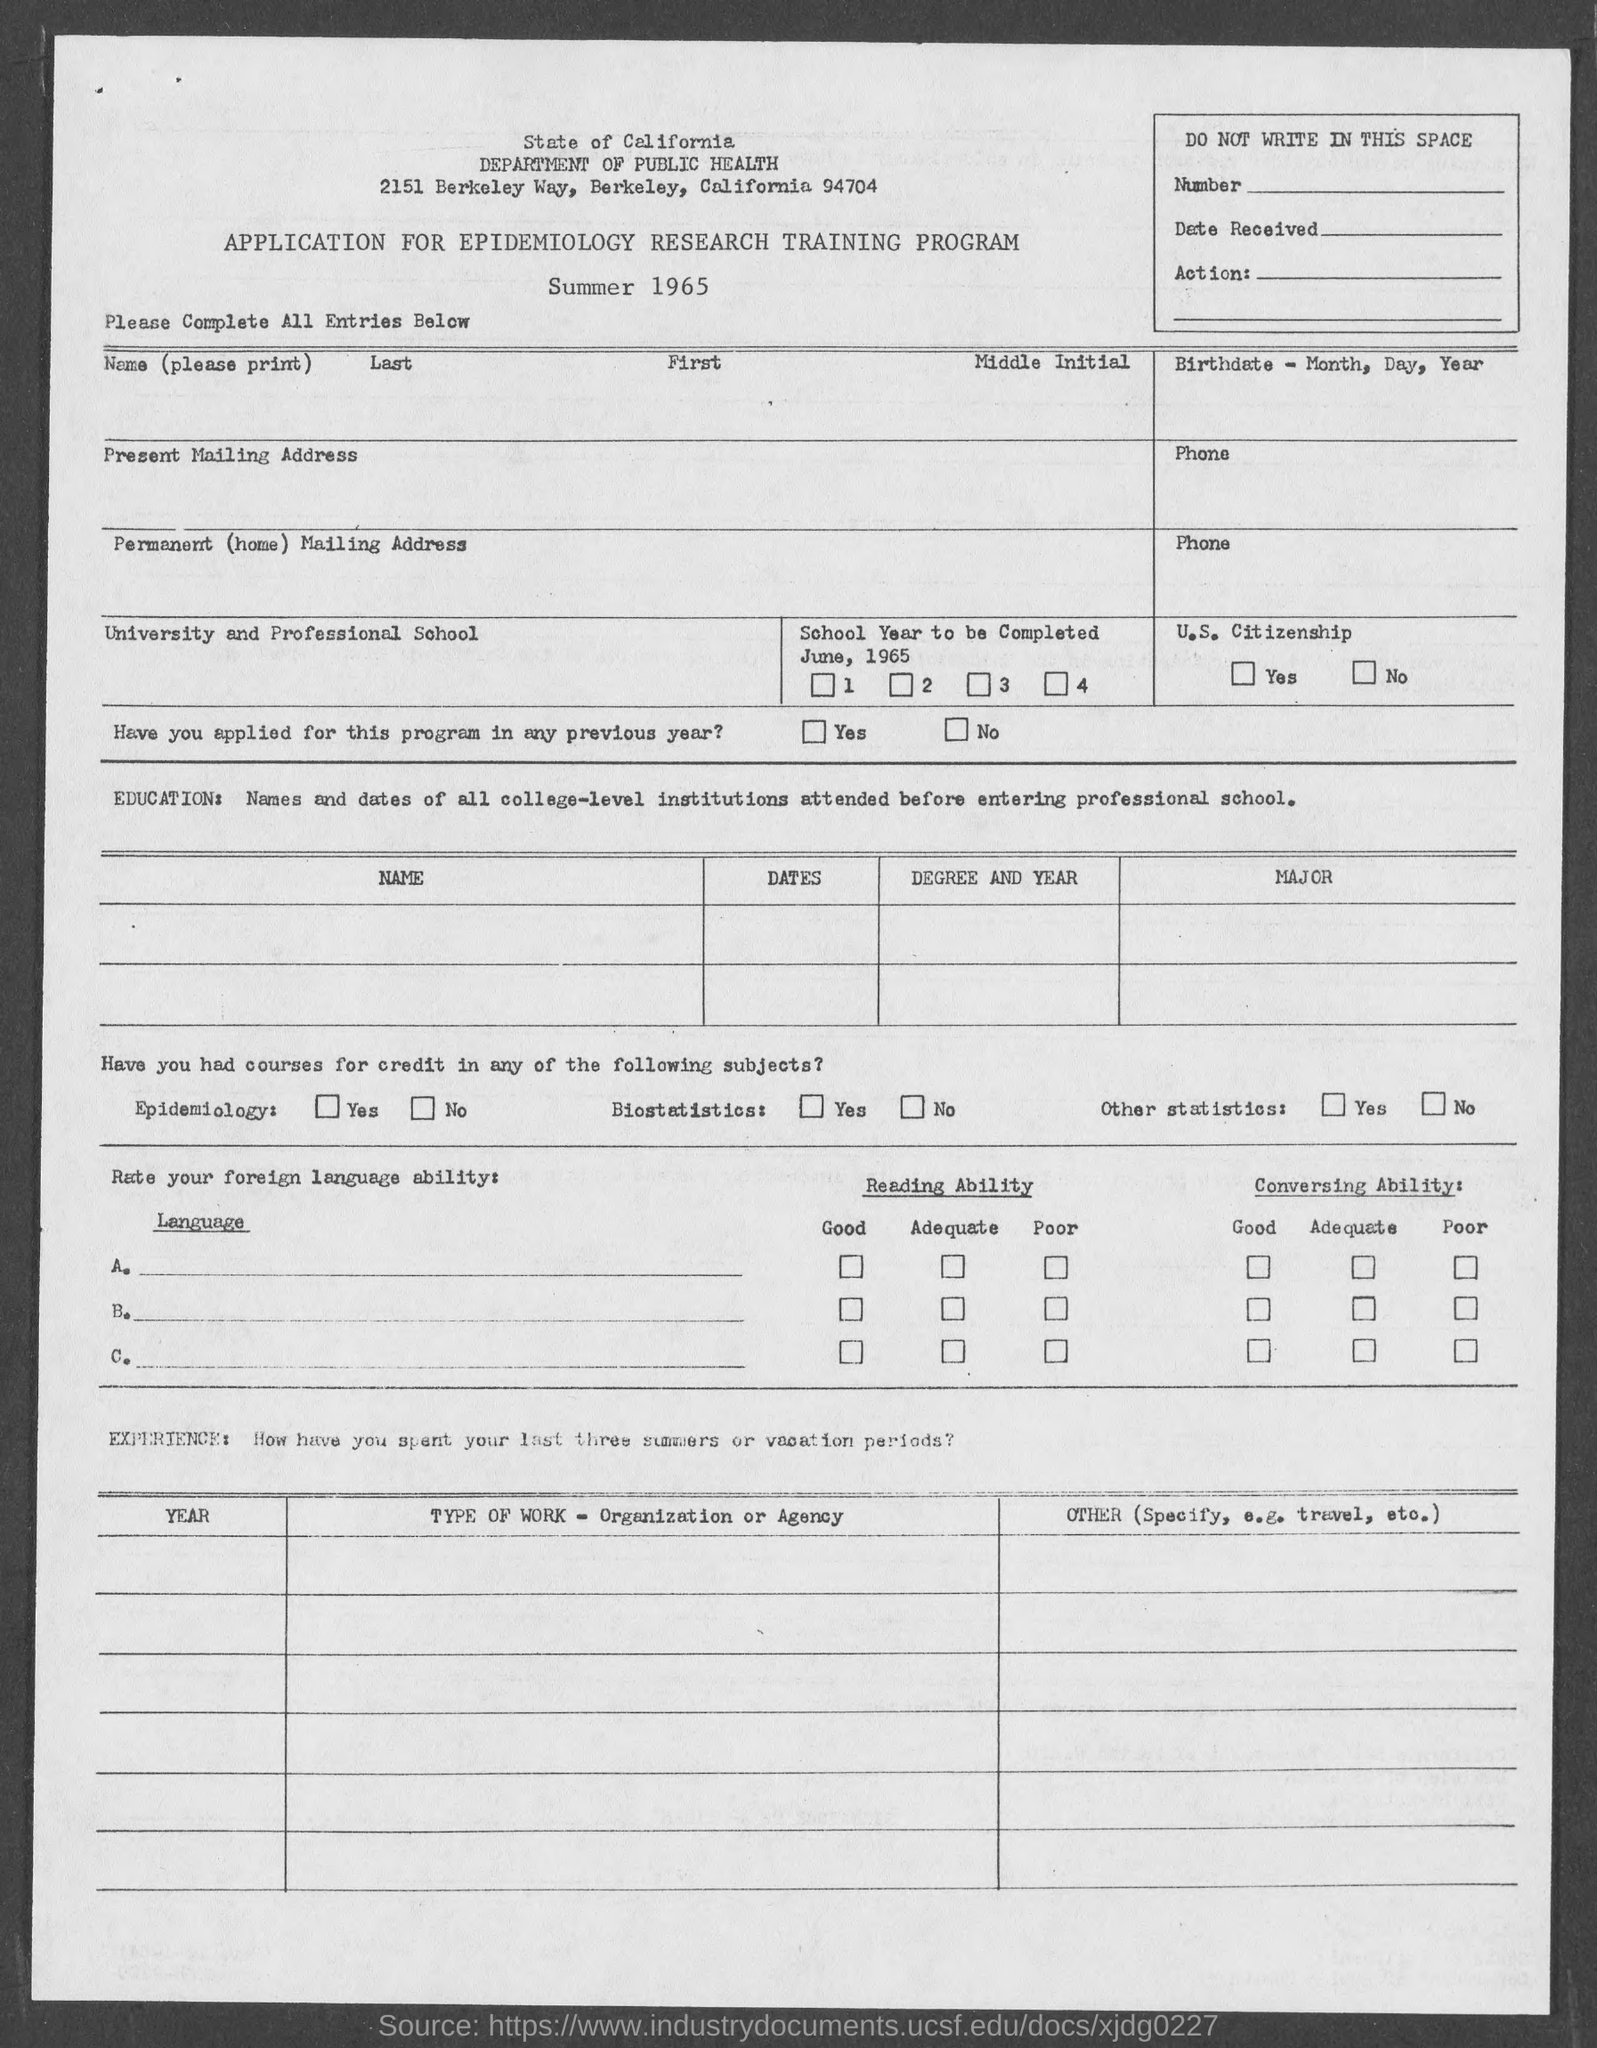Give some essential details in this illustration. The Department of Public Health in the State of California is located in Berkeley. 